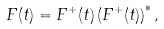Convert formula to latex. <formula><loc_0><loc_0><loc_500><loc_500>F ( t ) = F ^ { + } ( t ) \left ( F ^ { + } ( t ) \right ) ^ { * } ,</formula> 